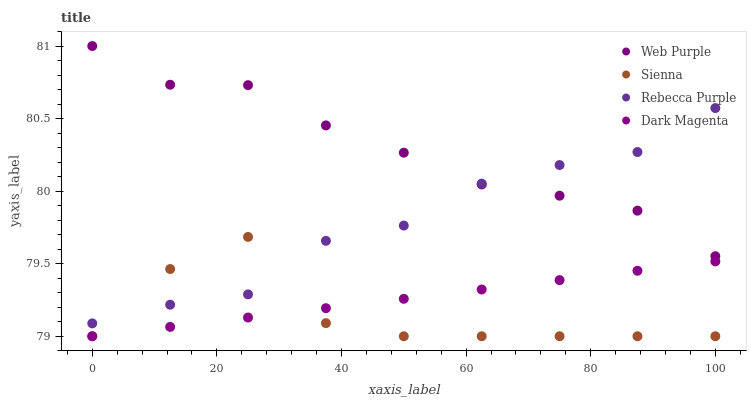Does Sienna have the minimum area under the curve?
Answer yes or no. Yes. Does Web Purple have the maximum area under the curve?
Answer yes or no. Yes. Does Rebecca Purple have the minimum area under the curve?
Answer yes or no. No. Does Rebecca Purple have the maximum area under the curve?
Answer yes or no. No. Is Dark Magenta the smoothest?
Answer yes or no. Yes. Is Sienna the roughest?
Answer yes or no. Yes. Is Web Purple the smoothest?
Answer yes or no. No. Is Web Purple the roughest?
Answer yes or no. No. Does Sienna have the lowest value?
Answer yes or no. Yes. Does Rebecca Purple have the lowest value?
Answer yes or no. No. Does Web Purple have the highest value?
Answer yes or no. Yes. Does Rebecca Purple have the highest value?
Answer yes or no. No. Is Dark Magenta less than Rebecca Purple?
Answer yes or no. Yes. Is Web Purple greater than Sienna?
Answer yes or no. Yes. Does Web Purple intersect Rebecca Purple?
Answer yes or no. Yes. Is Web Purple less than Rebecca Purple?
Answer yes or no. No. Is Web Purple greater than Rebecca Purple?
Answer yes or no. No. Does Dark Magenta intersect Rebecca Purple?
Answer yes or no. No. 